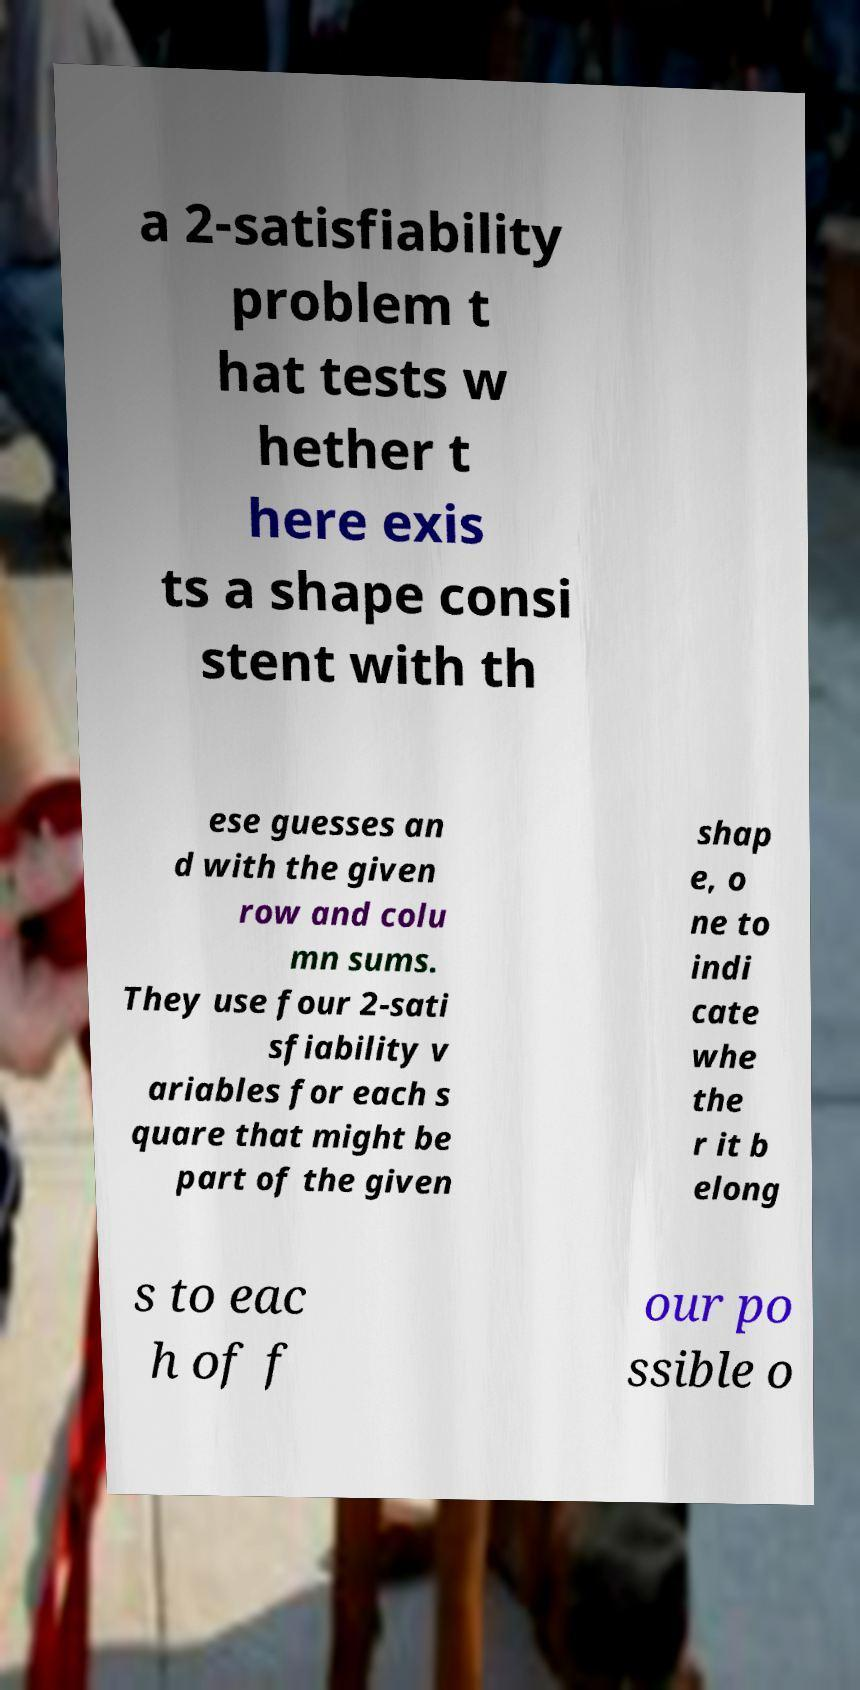Please identify and transcribe the text found in this image. a 2-satisfiability problem t hat tests w hether t here exis ts a shape consi stent with th ese guesses an d with the given row and colu mn sums. They use four 2-sati sfiability v ariables for each s quare that might be part of the given shap e, o ne to indi cate whe the r it b elong s to eac h of f our po ssible o 